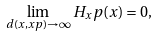Convert formula to latex. <formula><loc_0><loc_0><loc_500><loc_500>\lim _ { d ( x , x p ) \to \infty } H _ { x } p ( x ) = 0 ,</formula> 